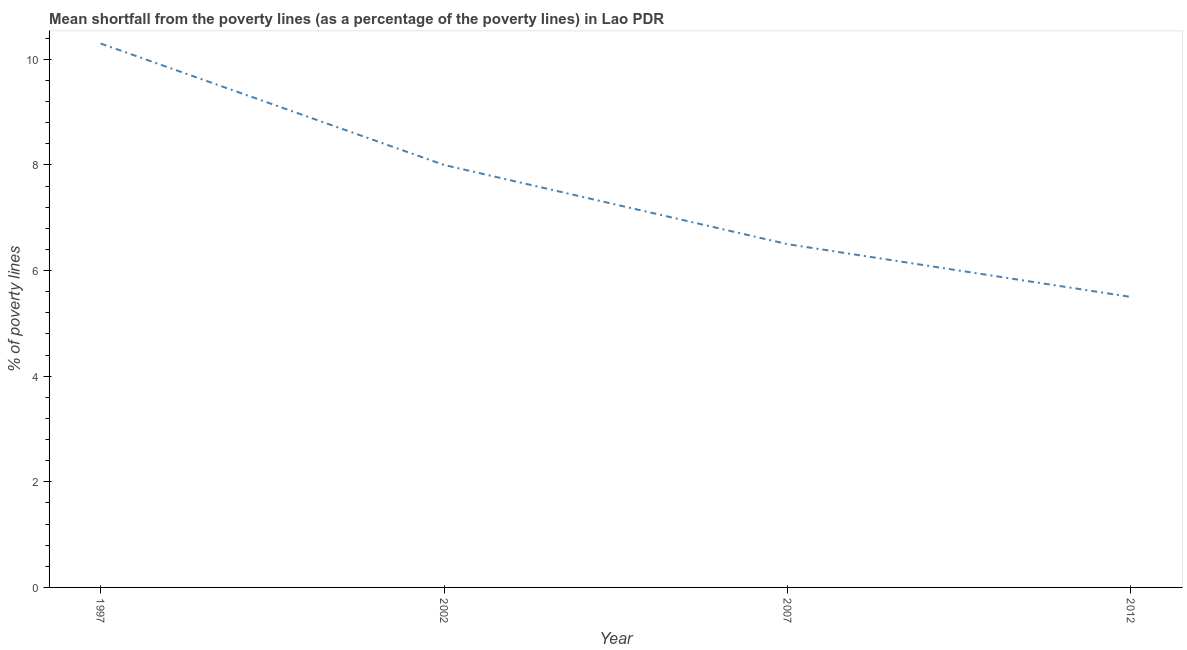Across all years, what is the minimum poverty gap at national poverty lines?
Your answer should be very brief. 5.5. In which year was the poverty gap at national poverty lines maximum?
Keep it short and to the point. 1997. In which year was the poverty gap at national poverty lines minimum?
Ensure brevity in your answer.  2012. What is the sum of the poverty gap at national poverty lines?
Offer a terse response. 30.3. What is the average poverty gap at national poverty lines per year?
Make the answer very short. 7.58. What is the median poverty gap at national poverty lines?
Provide a short and direct response. 7.25. In how many years, is the poverty gap at national poverty lines greater than 1.6 %?
Provide a short and direct response. 4. Do a majority of the years between 2012 and 2007 (inclusive) have poverty gap at national poverty lines greater than 6.8 %?
Provide a succinct answer. No. What is the ratio of the poverty gap at national poverty lines in 1997 to that in 2007?
Make the answer very short. 1.58. Is the poverty gap at national poverty lines in 1997 less than that in 2012?
Your answer should be very brief. No. What is the difference between the highest and the second highest poverty gap at national poverty lines?
Make the answer very short. 2.3. What is the difference between the highest and the lowest poverty gap at national poverty lines?
Make the answer very short. 4.8. In how many years, is the poverty gap at national poverty lines greater than the average poverty gap at national poverty lines taken over all years?
Make the answer very short. 2. How many lines are there?
Your response must be concise. 1. What is the difference between two consecutive major ticks on the Y-axis?
Ensure brevity in your answer.  2. Does the graph contain any zero values?
Provide a short and direct response. No. Does the graph contain grids?
Offer a terse response. No. What is the title of the graph?
Provide a succinct answer. Mean shortfall from the poverty lines (as a percentage of the poverty lines) in Lao PDR. What is the label or title of the X-axis?
Offer a terse response. Year. What is the label or title of the Y-axis?
Provide a succinct answer. % of poverty lines. What is the % of poverty lines in 2007?
Offer a terse response. 6.5. What is the difference between the % of poverty lines in 2002 and 2007?
Your answer should be very brief. 1.5. What is the difference between the % of poverty lines in 2007 and 2012?
Make the answer very short. 1. What is the ratio of the % of poverty lines in 1997 to that in 2002?
Offer a very short reply. 1.29. What is the ratio of the % of poverty lines in 1997 to that in 2007?
Keep it short and to the point. 1.58. What is the ratio of the % of poverty lines in 1997 to that in 2012?
Give a very brief answer. 1.87. What is the ratio of the % of poverty lines in 2002 to that in 2007?
Keep it short and to the point. 1.23. What is the ratio of the % of poverty lines in 2002 to that in 2012?
Ensure brevity in your answer.  1.46. What is the ratio of the % of poverty lines in 2007 to that in 2012?
Offer a terse response. 1.18. 